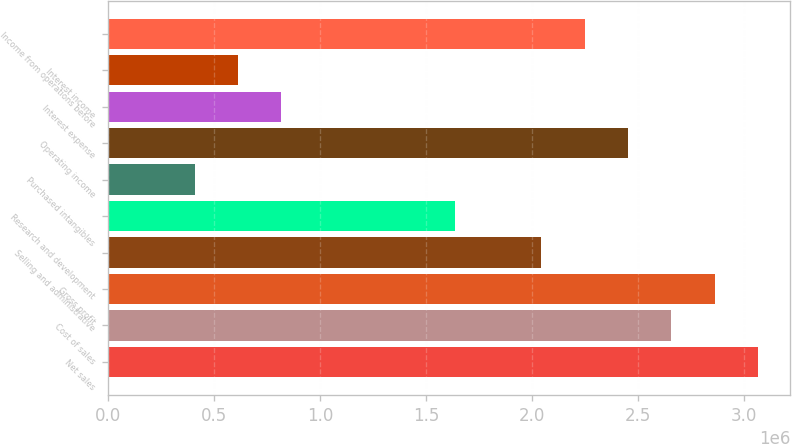Convert chart to OTSL. <chart><loc_0><loc_0><loc_500><loc_500><bar_chart><fcel>Net sales<fcel>Cost of sales<fcel>Gross profit<fcel>Selling and administrative<fcel>Research and development<fcel>Purchased intangibles<fcel>Operating income<fcel>Interest expense<fcel>Interest income<fcel>Income from operations before<nl><fcel>3.0635e+06<fcel>2.65503e+06<fcel>2.85926e+06<fcel>2.04233e+06<fcel>1.63387e+06<fcel>408471<fcel>2.4508e+06<fcel>816936<fcel>612704<fcel>2.24656e+06<nl></chart> 